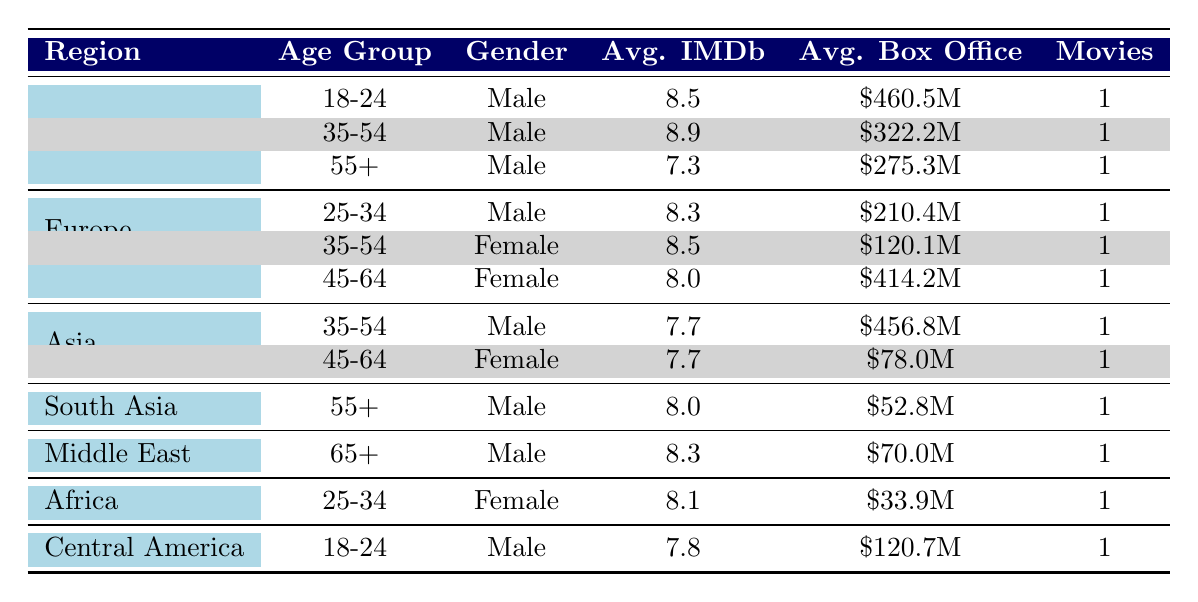What is the average IMDb rating for historical movies in North America? To find the average IMDb rating for historical movies in North America, we first look at the ratings for the relevant entries: 8.5 (Gladiator), 8.9 (Schindler's List), and 7.3 (Lincoln). We sum those values: 8.5 + 8.9 + 7.3 = 24.7. Since there are 3 movies, we divide by 3 to get the average: 24.7 / 3 = 8.23.
Answer: 8.23 Which region has the highest average box office? Looking at the box office values for each region: North America (322.2M + 460.5M + 275.3M = 1058M / 3 translates to about 352.67M), Europe (210.4M + 120.1M + 414.2M = 744.7M / 3 = about 248.23M), and others. North America has the highest average box office from the calculated sums.
Answer: North America Are there any historical movies in Africa with an average IMDb rating above 8? From the table, the only movie in Africa is Hotel Rwanda, which has an IMDb rating of 8.1. Since this rating is above 8, the answer is yes.
Answer: Yes What is the average IMDb rating for female audiences in Europe? The IMDb ratings for the female audience in Europe includes: 8.5 (The Pianist) and 8.0 (The King's Speech). To find the average, we sum up those ratings: 8.5 + 8.0 = 16.5, and since there are 2 movies, we divide by 2: 16.5 / 2 = 8.25.
Answer: 8.25 Which age group in North America has the lowest average IMDb rating? In North America, the age groups are 18-24 with a rating of 8.5, 35-54 with 8.9, and 55+ with 7.3. The lowest rating among these is from the 55+ age group with a rating of 7.3.
Answer: 55+ How many movies are targeted at males aged 35-54 across all regions? The movies targeted at males aged 35-54 from the table are 8.9 (Schindler's List) and 7.7 (The Last Samurai). Therefore, there are 2 movies targeted at this demographic.
Answer: 2 